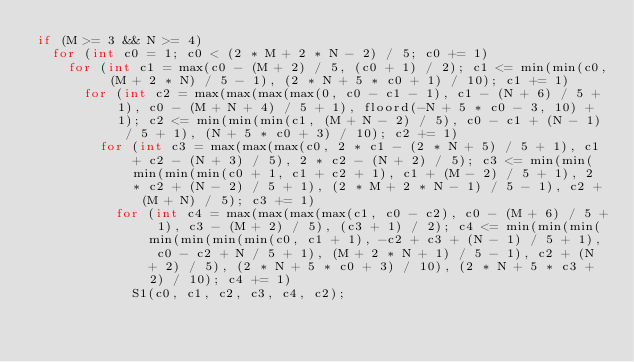<code> <loc_0><loc_0><loc_500><loc_500><_C_>if (M >= 3 && N >= 4)
  for (int c0 = 1; c0 < (2 * M + 2 * N - 2) / 5; c0 += 1)
    for (int c1 = max(c0 - (M + 2) / 5, (c0 + 1) / 2); c1 <= min(min(c0, (M + 2 * N) / 5 - 1), (2 * N + 5 * c0 + 1) / 10); c1 += 1)
      for (int c2 = max(max(max(max(0, c0 - c1 - 1), c1 - (N + 6) / 5 + 1), c0 - (M + N + 4) / 5 + 1), floord(-N + 5 * c0 - 3, 10) + 1); c2 <= min(min(min(c1, (M + N - 2) / 5), c0 - c1 + (N - 1) / 5 + 1), (N + 5 * c0 + 3) / 10); c2 += 1)
        for (int c3 = max(max(max(c0, 2 * c1 - (2 * N + 5) / 5 + 1), c1 + c2 - (N + 3) / 5), 2 * c2 - (N + 2) / 5); c3 <= min(min(min(min(min(c0 + 1, c1 + c2 + 1), c1 + (M - 2) / 5 + 1), 2 * c2 + (N - 2) / 5 + 1), (2 * M + 2 * N - 1) / 5 - 1), c2 + (M + N) / 5); c3 += 1)
          for (int c4 = max(max(max(max(c1, c0 - c2), c0 - (M + 6) / 5 + 1), c3 - (M + 2) / 5), (c3 + 1) / 2); c4 <= min(min(min(min(min(min(min(c0, c1 + 1), -c2 + c3 + (N - 1) / 5 + 1), c0 - c2 + N / 5 + 1), (M + 2 * N + 1) / 5 - 1), c2 + (N + 2) / 5), (2 * N + 5 * c0 + 3) / 10), (2 * N + 5 * c3 + 2) / 10); c4 += 1)
            S1(c0, c1, c2, c3, c4, c2);
</code> 